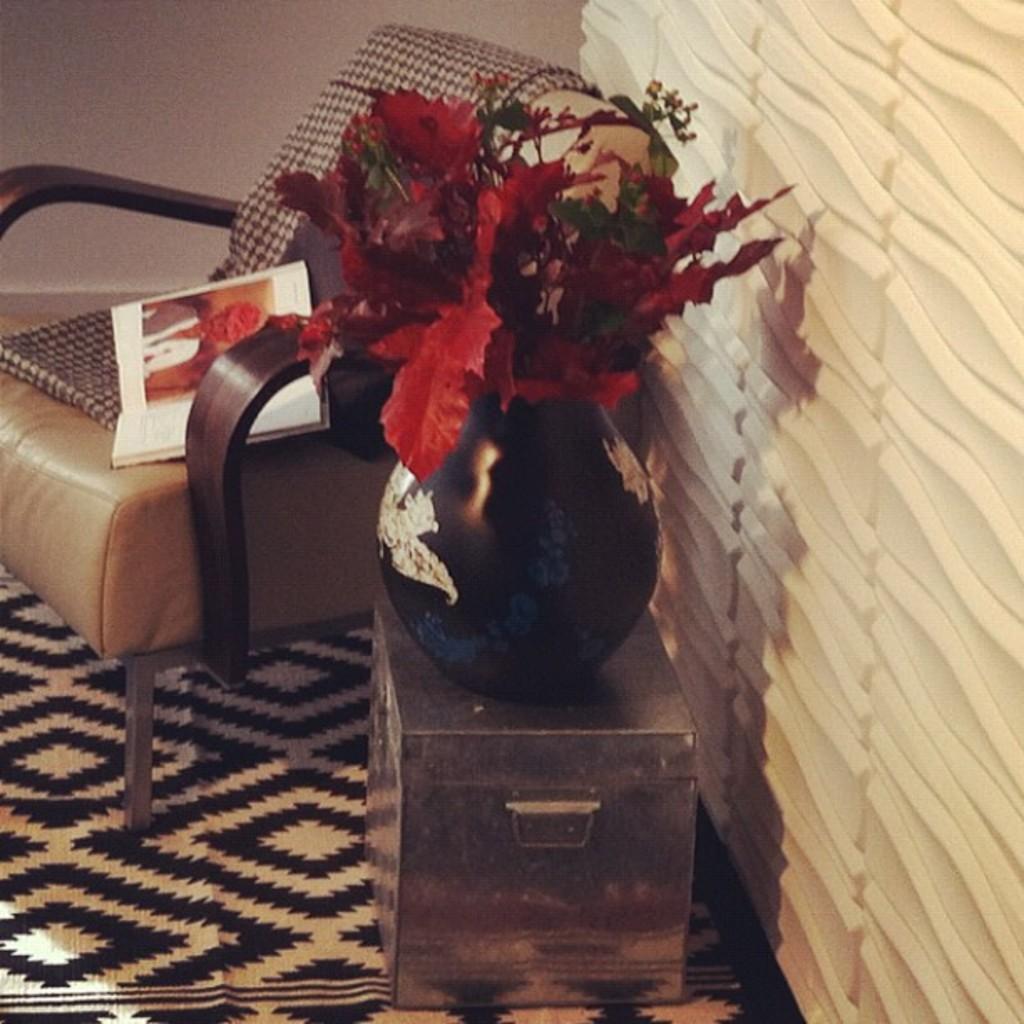How would you summarize this image in a sentence or two? In this picture we can see a chair here, behind it there is a flower vase, we can see flowers here, there is a book present on the chair, at the bottom there is mat, we can see a wall in the background. 